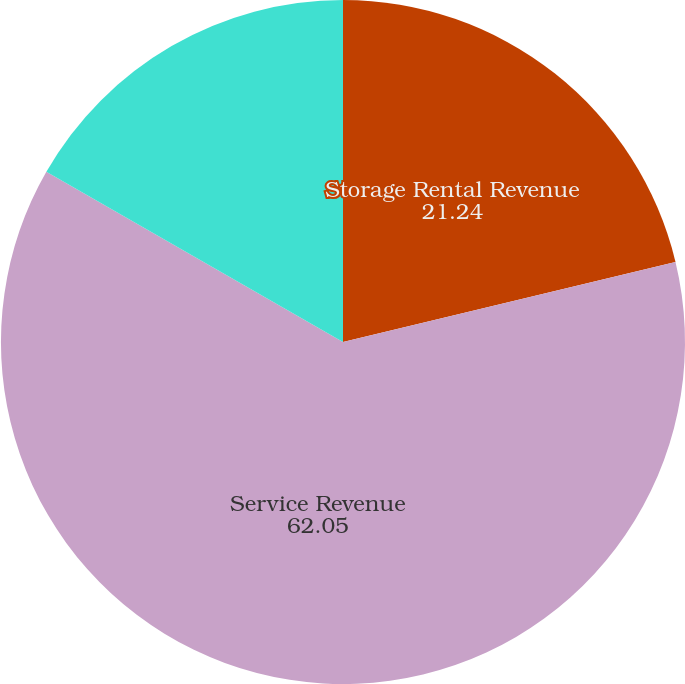Convert chart to OTSL. <chart><loc_0><loc_0><loc_500><loc_500><pie_chart><fcel>Storage Rental Revenue<fcel>Service Revenue<fcel>Total Revenue<nl><fcel>21.24%<fcel>62.05%<fcel>16.71%<nl></chart> 